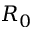Convert formula to latex. <formula><loc_0><loc_0><loc_500><loc_500>R _ { 0 }</formula> 